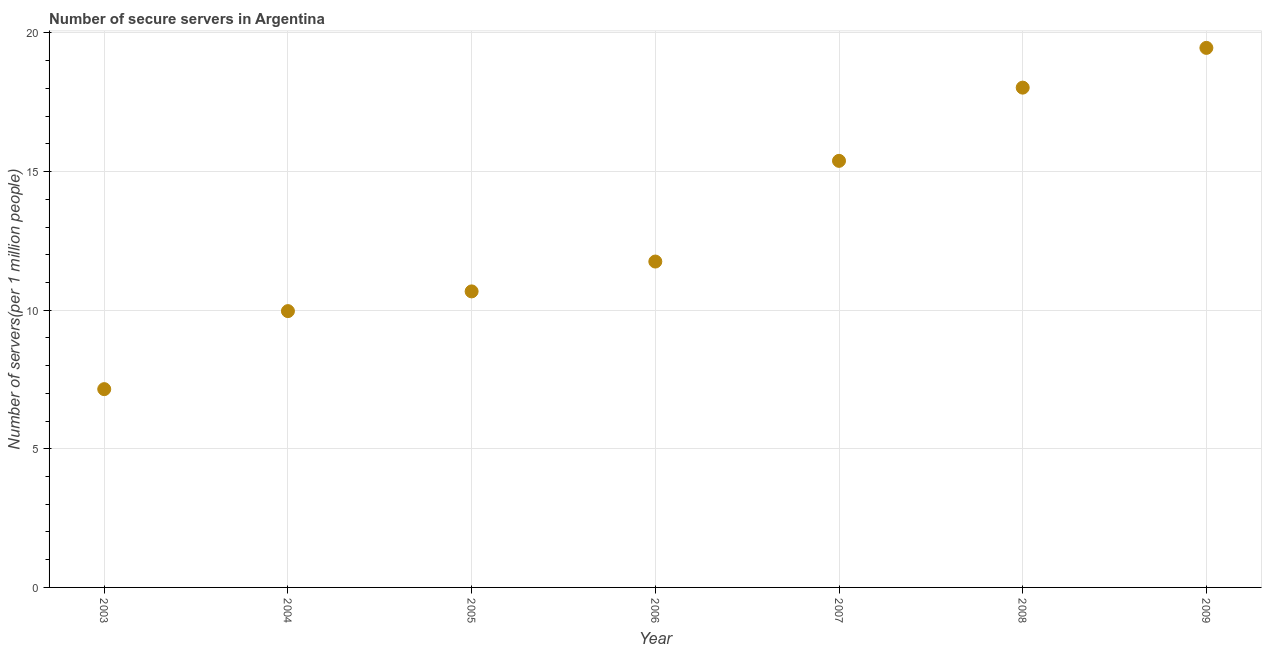What is the number of secure internet servers in 2003?
Make the answer very short. 7.15. Across all years, what is the maximum number of secure internet servers?
Keep it short and to the point. 19.46. Across all years, what is the minimum number of secure internet servers?
Offer a very short reply. 7.15. In which year was the number of secure internet servers minimum?
Your response must be concise. 2003. What is the sum of the number of secure internet servers?
Your answer should be very brief. 92.43. What is the difference between the number of secure internet servers in 2003 and 2007?
Ensure brevity in your answer.  -8.23. What is the average number of secure internet servers per year?
Your response must be concise. 13.2. What is the median number of secure internet servers?
Your response must be concise. 11.75. In how many years, is the number of secure internet servers greater than 18 ?
Give a very brief answer. 2. What is the ratio of the number of secure internet servers in 2003 to that in 2008?
Make the answer very short. 0.4. Is the number of secure internet servers in 2004 less than that in 2009?
Your answer should be compact. Yes. What is the difference between the highest and the second highest number of secure internet servers?
Keep it short and to the point. 1.43. Is the sum of the number of secure internet servers in 2005 and 2007 greater than the maximum number of secure internet servers across all years?
Make the answer very short. Yes. What is the difference between the highest and the lowest number of secure internet servers?
Offer a very short reply. 12.31. What is the difference between two consecutive major ticks on the Y-axis?
Ensure brevity in your answer.  5. Does the graph contain any zero values?
Provide a short and direct response. No. Does the graph contain grids?
Your answer should be compact. Yes. What is the title of the graph?
Provide a short and direct response. Number of secure servers in Argentina. What is the label or title of the Y-axis?
Provide a succinct answer. Number of servers(per 1 million people). What is the Number of servers(per 1 million people) in 2003?
Make the answer very short. 7.15. What is the Number of servers(per 1 million people) in 2004?
Your answer should be compact. 9.97. What is the Number of servers(per 1 million people) in 2005?
Your response must be concise. 10.68. What is the Number of servers(per 1 million people) in 2006?
Your response must be concise. 11.75. What is the Number of servers(per 1 million people) in 2007?
Your answer should be compact. 15.39. What is the Number of servers(per 1 million people) in 2008?
Provide a short and direct response. 18.03. What is the Number of servers(per 1 million people) in 2009?
Offer a very short reply. 19.46. What is the difference between the Number of servers(per 1 million people) in 2003 and 2004?
Offer a very short reply. -2.81. What is the difference between the Number of servers(per 1 million people) in 2003 and 2005?
Provide a succinct answer. -3.53. What is the difference between the Number of servers(per 1 million people) in 2003 and 2006?
Give a very brief answer. -4.6. What is the difference between the Number of servers(per 1 million people) in 2003 and 2007?
Make the answer very short. -8.23. What is the difference between the Number of servers(per 1 million people) in 2003 and 2008?
Keep it short and to the point. -10.88. What is the difference between the Number of servers(per 1 million people) in 2003 and 2009?
Your answer should be compact. -12.31. What is the difference between the Number of servers(per 1 million people) in 2004 and 2005?
Ensure brevity in your answer.  -0.71. What is the difference between the Number of servers(per 1 million people) in 2004 and 2006?
Offer a very short reply. -1.79. What is the difference between the Number of servers(per 1 million people) in 2004 and 2007?
Give a very brief answer. -5.42. What is the difference between the Number of servers(per 1 million people) in 2004 and 2008?
Your response must be concise. -8.06. What is the difference between the Number of servers(per 1 million people) in 2004 and 2009?
Give a very brief answer. -9.49. What is the difference between the Number of servers(per 1 million people) in 2005 and 2006?
Make the answer very short. -1.08. What is the difference between the Number of servers(per 1 million people) in 2005 and 2007?
Your response must be concise. -4.71. What is the difference between the Number of servers(per 1 million people) in 2005 and 2008?
Give a very brief answer. -7.35. What is the difference between the Number of servers(per 1 million people) in 2005 and 2009?
Keep it short and to the point. -8.78. What is the difference between the Number of servers(per 1 million people) in 2006 and 2007?
Keep it short and to the point. -3.63. What is the difference between the Number of servers(per 1 million people) in 2006 and 2008?
Offer a very short reply. -6.27. What is the difference between the Number of servers(per 1 million people) in 2006 and 2009?
Give a very brief answer. -7.71. What is the difference between the Number of servers(per 1 million people) in 2007 and 2008?
Provide a short and direct response. -2.64. What is the difference between the Number of servers(per 1 million people) in 2007 and 2009?
Provide a short and direct response. -4.07. What is the difference between the Number of servers(per 1 million people) in 2008 and 2009?
Ensure brevity in your answer.  -1.43. What is the ratio of the Number of servers(per 1 million people) in 2003 to that in 2004?
Provide a succinct answer. 0.72. What is the ratio of the Number of servers(per 1 million people) in 2003 to that in 2005?
Provide a succinct answer. 0.67. What is the ratio of the Number of servers(per 1 million people) in 2003 to that in 2006?
Provide a succinct answer. 0.61. What is the ratio of the Number of servers(per 1 million people) in 2003 to that in 2007?
Ensure brevity in your answer.  0.47. What is the ratio of the Number of servers(per 1 million people) in 2003 to that in 2008?
Give a very brief answer. 0.4. What is the ratio of the Number of servers(per 1 million people) in 2003 to that in 2009?
Offer a terse response. 0.37. What is the ratio of the Number of servers(per 1 million people) in 2004 to that in 2005?
Offer a very short reply. 0.93. What is the ratio of the Number of servers(per 1 million people) in 2004 to that in 2006?
Give a very brief answer. 0.85. What is the ratio of the Number of servers(per 1 million people) in 2004 to that in 2007?
Offer a very short reply. 0.65. What is the ratio of the Number of servers(per 1 million people) in 2004 to that in 2008?
Make the answer very short. 0.55. What is the ratio of the Number of servers(per 1 million people) in 2004 to that in 2009?
Keep it short and to the point. 0.51. What is the ratio of the Number of servers(per 1 million people) in 2005 to that in 2006?
Keep it short and to the point. 0.91. What is the ratio of the Number of servers(per 1 million people) in 2005 to that in 2007?
Your response must be concise. 0.69. What is the ratio of the Number of servers(per 1 million people) in 2005 to that in 2008?
Provide a short and direct response. 0.59. What is the ratio of the Number of servers(per 1 million people) in 2005 to that in 2009?
Provide a succinct answer. 0.55. What is the ratio of the Number of servers(per 1 million people) in 2006 to that in 2007?
Your response must be concise. 0.76. What is the ratio of the Number of servers(per 1 million people) in 2006 to that in 2008?
Offer a very short reply. 0.65. What is the ratio of the Number of servers(per 1 million people) in 2006 to that in 2009?
Offer a terse response. 0.6. What is the ratio of the Number of servers(per 1 million people) in 2007 to that in 2008?
Make the answer very short. 0.85. What is the ratio of the Number of servers(per 1 million people) in 2007 to that in 2009?
Keep it short and to the point. 0.79. What is the ratio of the Number of servers(per 1 million people) in 2008 to that in 2009?
Give a very brief answer. 0.93. 